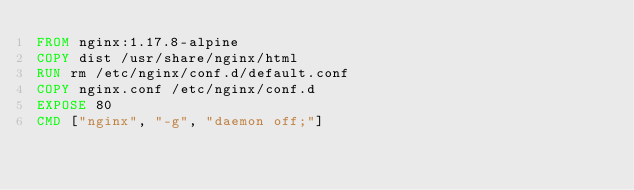<code> <loc_0><loc_0><loc_500><loc_500><_Dockerfile_>FROM nginx:1.17.8-alpine
COPY dist /usr/share/nginx/html
RUN rm /etc/nginx/conf.d/default.conf
COPY nginx.conf /etc/nginx/conf.d
EXPOSE 80
CMD ["nginx", "-g", "daemon off;"]</code> 